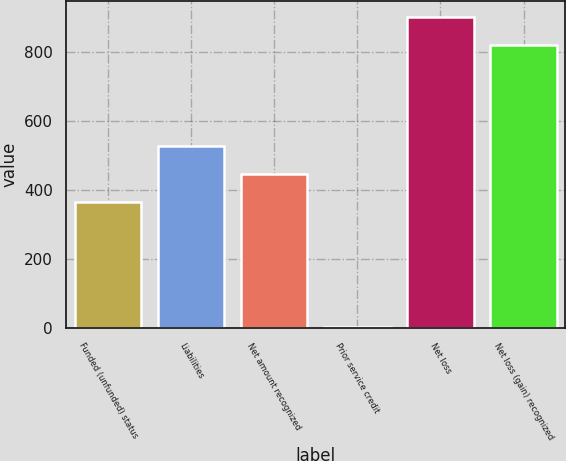Convert chart to OTSL. <chart><loc_0><loc_0><loc_500><loc_500><bar_chart><fcel>Funded (unfunded) status<fcel>Liabilities<fcel>Net amount recognized<fcel>Prior service credit<fcel>Net loss<fcel>Net loss (gain) recognized<nl><fcel>364<fcel>527.8<fcel>445.9<fcel>2<fcel>900.9<fcel>819<nl></chart> 